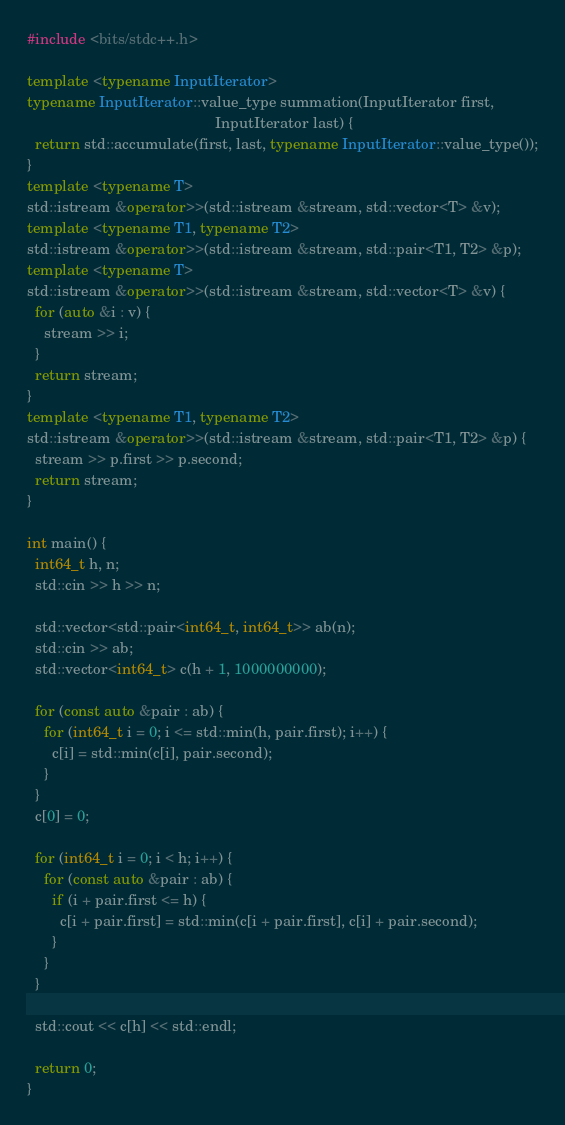<code> <loc_0><loc_0><loc_500><loc_500><_C++_>#include <bits/stdc++.h>

template <typename InputIterator>
typename InputIterator::value_type summation(InputIterator first,
                                             InputIterator last) {
  return std::accumulate(first, last, typename InputIterator::value_type());
}
template <typename T>
std::istream &operator>>(std::istream &stream, std::vector<T> &v);
template <typename T1, typename T2>
std::istream &operator>>(std::istream &stream, std::pair<T1, T2> &p);
template <typename T>
std::istream &operator>>(std::istream &stream, std::vector<T> &v) {
  for (auto &i : v) {
    stream >> i;
  }
  return stream;
}
template <typename T1, typename T2>
std::istream &operator>>(std::istream &stream, std::pair<T1, T2> &p) {
  stream >> p.first >> p.second;
  return stream;
}

int main() {
  int64_t h, n;
  std::cin >> h >> n;

  std::vector<std::pair<int64_t, int64_t>> ab(n);
  std::cin >> ab;
  std::vector<int64_t> c(h + 1, 1000000000);

  for (const auto &pair : ab) {
    for (int64_t i = 0; i <= std::min(h, pair.first); i++) {
      c[i] = std::min(c[i], pair.second);
    }
  }
  c[0] = 0;

  for (int64_t i = 0; i < h; i++) {
    for (const auto &pair : ab) {
      if (i + pair.first <= h) {
        c[i + pair.first] = std::min(c[i + pair.first], c[i] + pair.second);
      }
    }
  }

  std::cout << c[h] << std::endl;

  return 0;
}</code> 